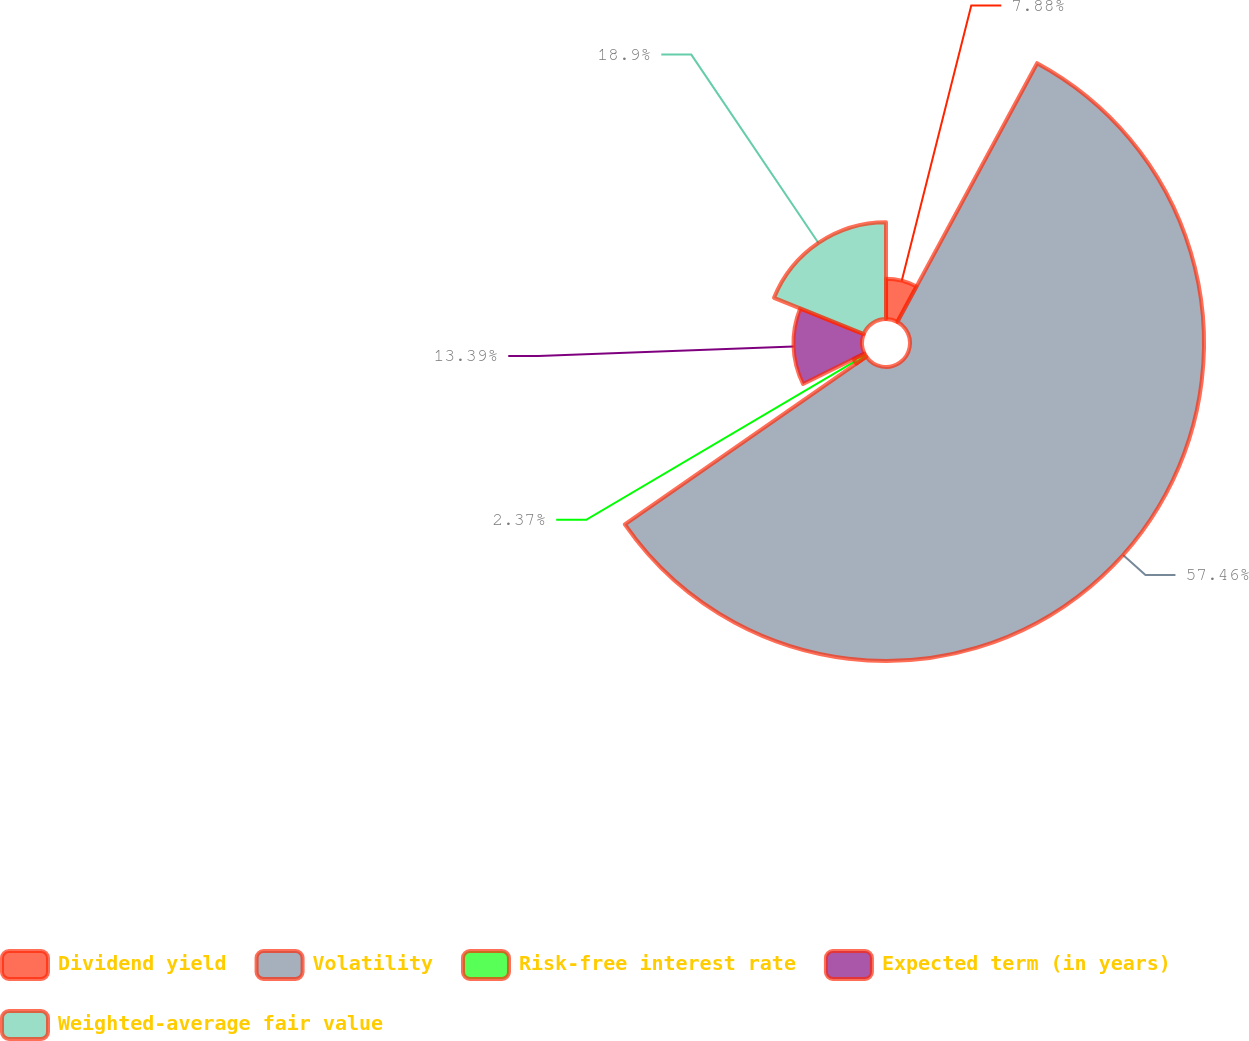<chart> <loc_0><loc_0><loc_500><loc_500><pie_chart><fcel>Dividend yield<fcel>Volatility<fcel>Risk-free interest rate<fcel>Expected term (in years)<fcel>Weighted-average fair value<nl><fcel>7.88%<fcel>57.45%<fcel>2.37%<fcel>13.39%<fcel>18.9%<nl></chart> 